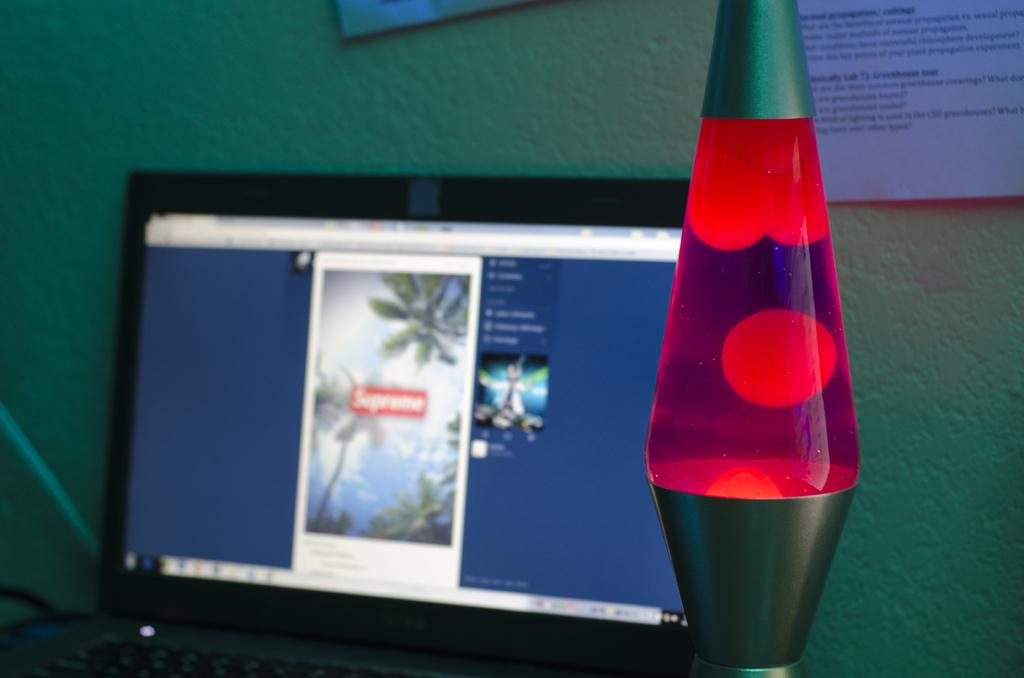<image>
Offer a succinct explanation of the picture presented. a computer screen is open, a lava lamp is beside it, and behind it is a paper with writing about a greenhouse 